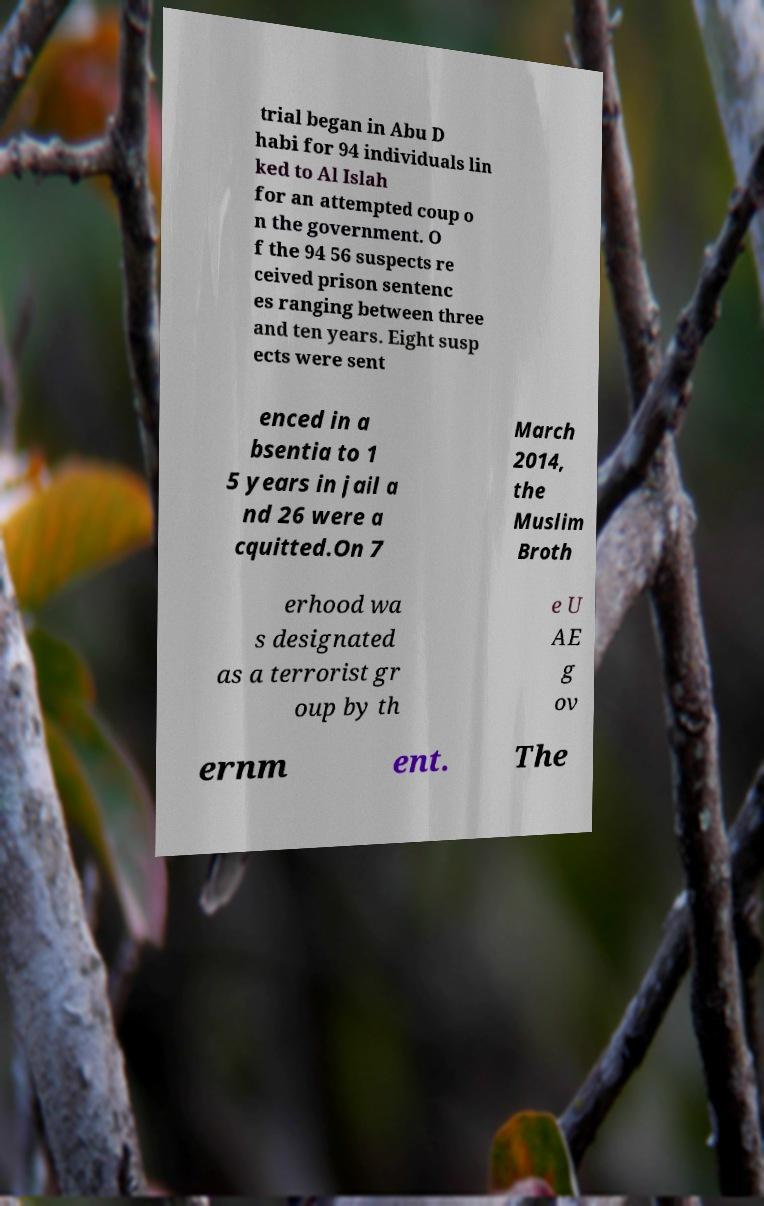For documentation purposes, I need the text within this image transcribed. Could you provide that? trial began in Abu D habi for 94 individuals lin ked to Al Islah for an attempted coup o n the government. O f the 94 56 suspects re ceived prison sentenc es ranging between three and ten years. Eight susp ects were sent enced in a bsentia to 1 5 years in jail a nd 26 were a cquitted.On 7 March 2014, the Muslim Broth erhood wa s designated as a terrorist gr oup by th e U AE g ov ernm ent. The 